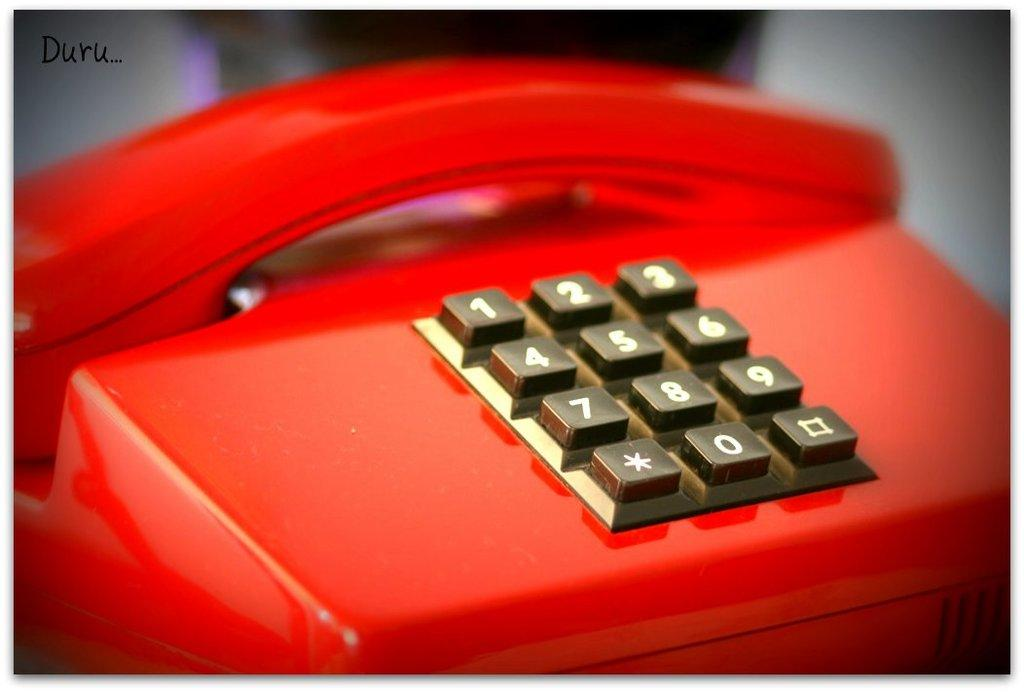What type of telephone is in the image? There is a red telephone in the image. What can be found on the telephone? The telephone has numbers on it. Can you describe the background of the image? The background of the image is blurry. How many tomatoes are on the goat in the image? There is no goat or tomatoes present in the image; it features a red telephone with numbers on it. 